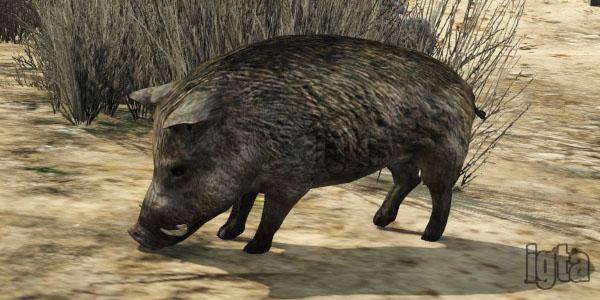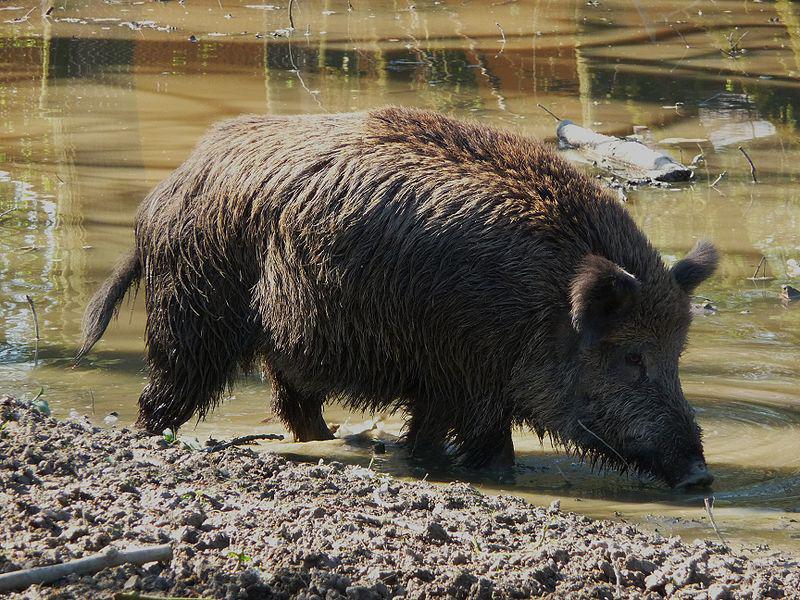The first image is the image on the left, the second image is the image on the right. Assess this claim about the two images: "At least one image features multiple full grown warthogs.". Correct or not? Answer yes or no. No. 